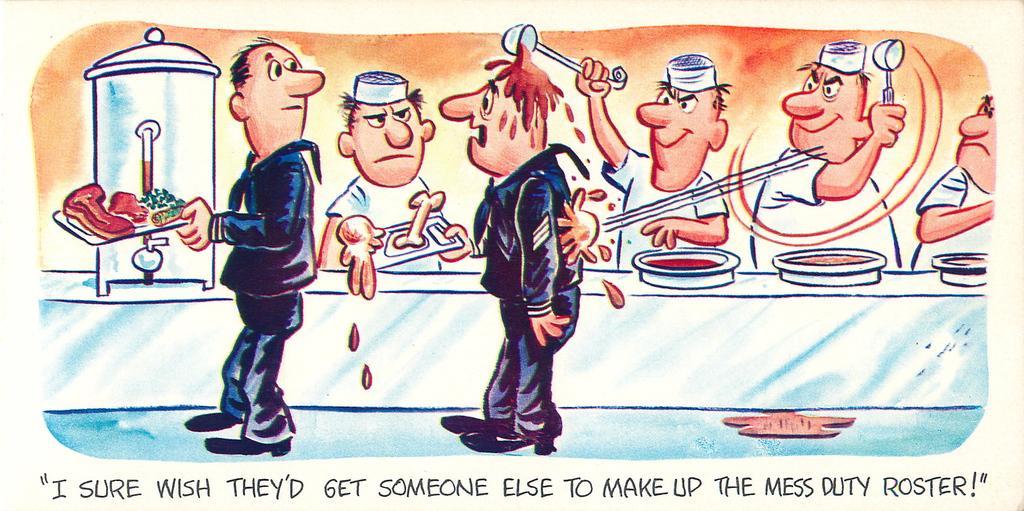How would you summarize this image in a sentence or two? In this image, there is a picture, on that picture there are some people serving the food and there is "I SURE WISH THAT GET SOMEONE ELSE TO TAKE THE MESS ROSTER" is written. 